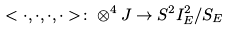<formula> <loc_0><loc_0><loc_500><loc_500>< \cdot , \cdot , \cdot , \cdot > \colon \otimes ^ { 4 } J \to S ^ { 2 } I ^ { 2 } _ { E } / S _ { E }</formula> 